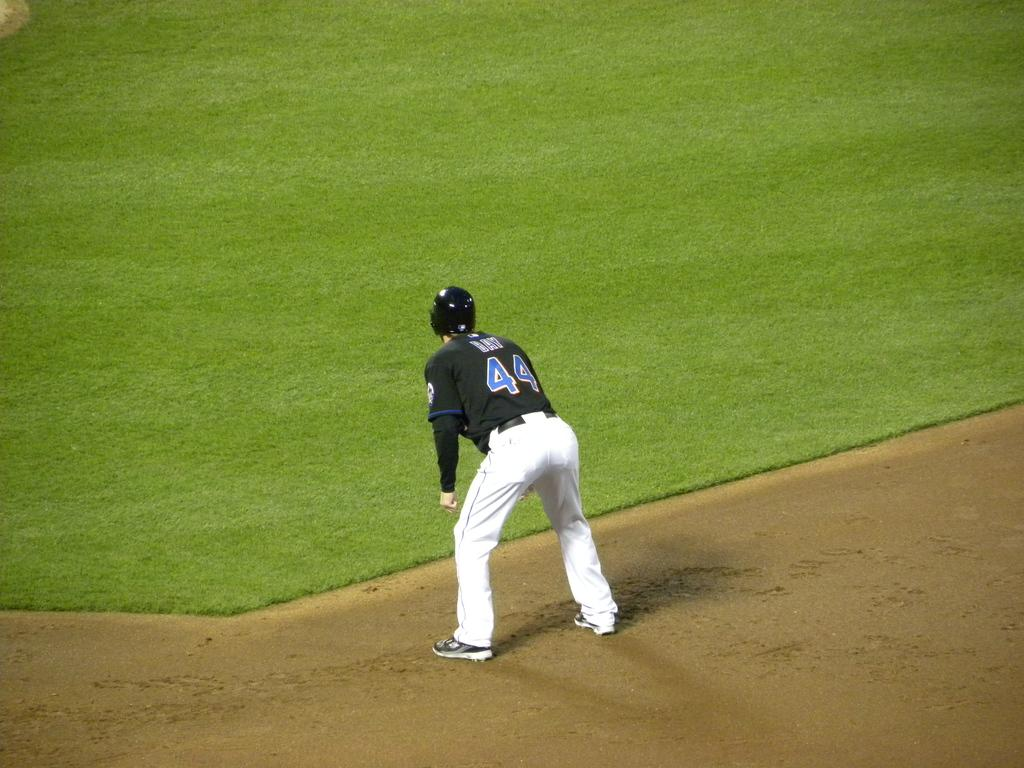<image>
Offer a succinct explanation of the picture presented. a player with the number 44 on their jersey 